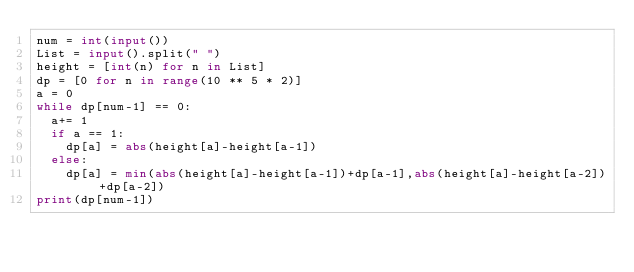Convert code to text. <code><loc_0><loc_0><loc_500><loc_500><_Python_>num = int(input())
List = input().split(" ")
height = [int(n) for n in List]
dp = [0 for n in range(10 ** 5 * 2)]
a = 0
while dp[num-1] == 0:
  a+= 1
  if a == 1:
    dp[a] = abs(height[a]-height[a-1])
  else:
    dp[a] = min(abs(height[a]-height[a-1])+dp[a-1],abs(height[a]-height[a-2])+dp[a-2])
print(dp[num-1])</code> 